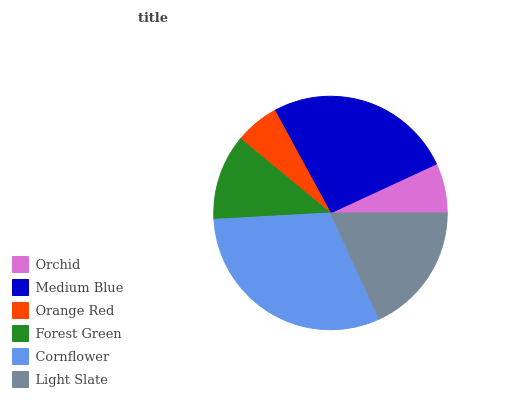Is Orange Red the minimum?
Answer yes or no. Yes. Is Cornflower the maximum?
Answer yes or no. Yes. Is Medium Blue the minimum?
Answer yes or no. No. Is Medium Blue the maximum?
Answer yes or no. No. Is Medium Blue greater than Orchid?
Answer yes or no. Yes. Is Orchid less than Medium Blue?
Answer yes or no. Yes. Is Orchid greater than Medium Blue?
Answer yes or no. No. Is Medium Blue less than Orchid?
Answer yes or no. No. Is Light Slate the high median?
Answer yes or no. Yes. Is Forest Green the low median?
Answer yes or no. Yes. Is Medium Blue the high median?
Answer yes or no. No. Is Orange Red the low median?
Answer yes or no. No. 